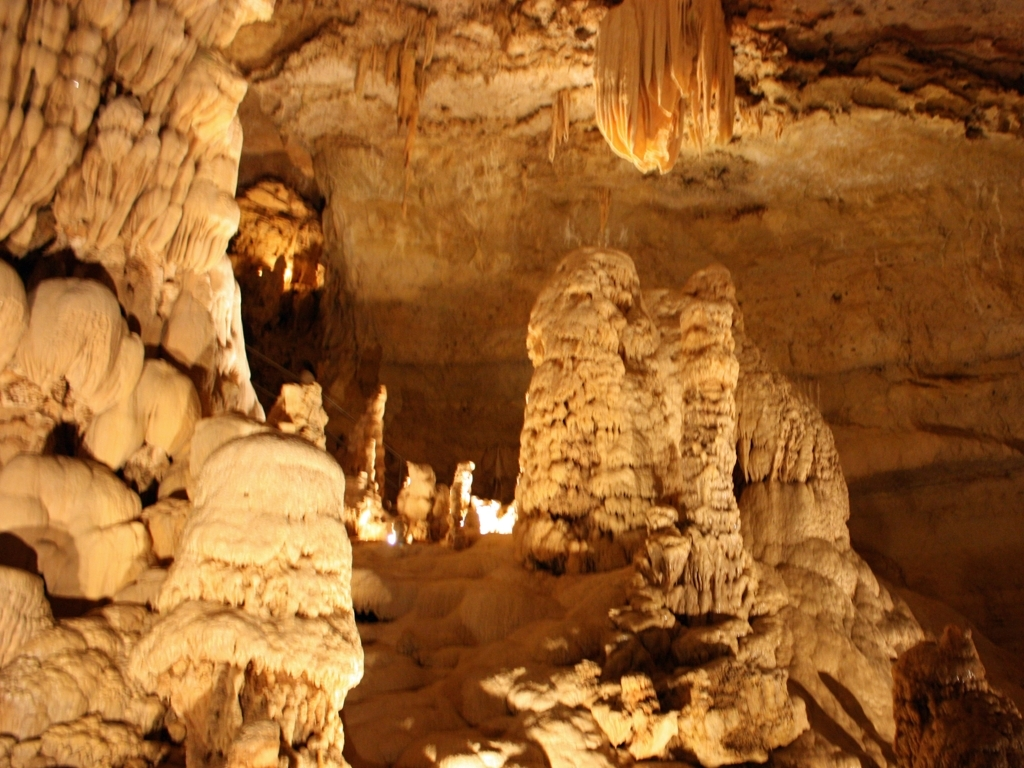Can you describe the geological formations in this image? Certainly! The image displays various speleothems, which are cave formations created by the deposition of minerals. Prominent among them are stalagmites, which rise from the floor, and stalactites, which hang from the ceiling. The lighting accentuates their layered structures, showcasing the gradual accumulation of mineral deposits over time. 